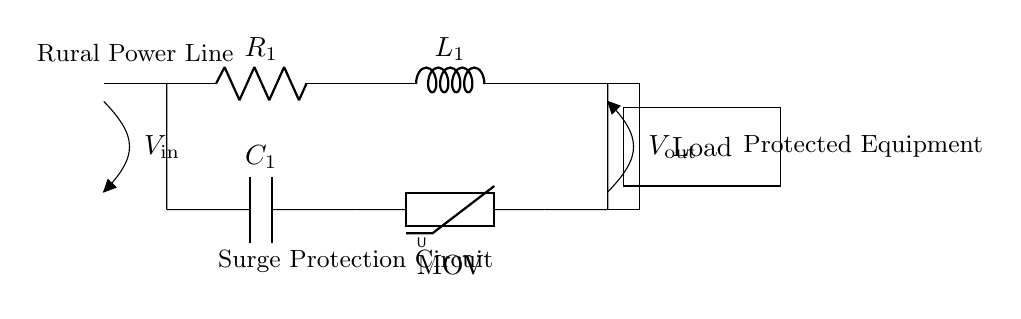What components are present in the circuit? The circuit contains a resistor, inductor, capacitor, and a metal oxide varistor. These components are identified by their symbols in the circuit diagram.
Answer: resistor, inductor, capacitor, metal oxide varistor What is the input voltage of this circuit? The input voltage is indicated at the leftmost side of the diagram, labeled as V_in, which does not have a specified value in the drawing.
Answer: V_in What is the purpose of the varistor in this circuit? The varistor is used for surge protection, as it limits voltage spikes by changing resistance with varying voltage levels. Its presence indicates an intention to protect the load from high voltage surges.
Answer: surge protection How are the components connected in this circuit? The components are connected in series, as each component is aligned horizontally and directly connected end-to-end. This configuration allows for a continuous path for current flow.
Answer: series What happens to excess voltage in this circuit? Excess voltage is clamped and dissipated by the varistor, which prevents it from reaching the load. This process protects the circuit from damage due to surges.
Answer: clamped by varistor Which component affects the circuit's response time the most? The inductor affects the circuit's response time significantly due to its property of opposing changes in current, which can result in delays in current response during surges.
Answer: inductor What type of circuit is this an example of? This is an example of an RLC circuit, specifically designed for surge protection in electrical systems. The combination of resistor, inductor, and capacitor highlights its categorization.
Answer: RLC circuit 